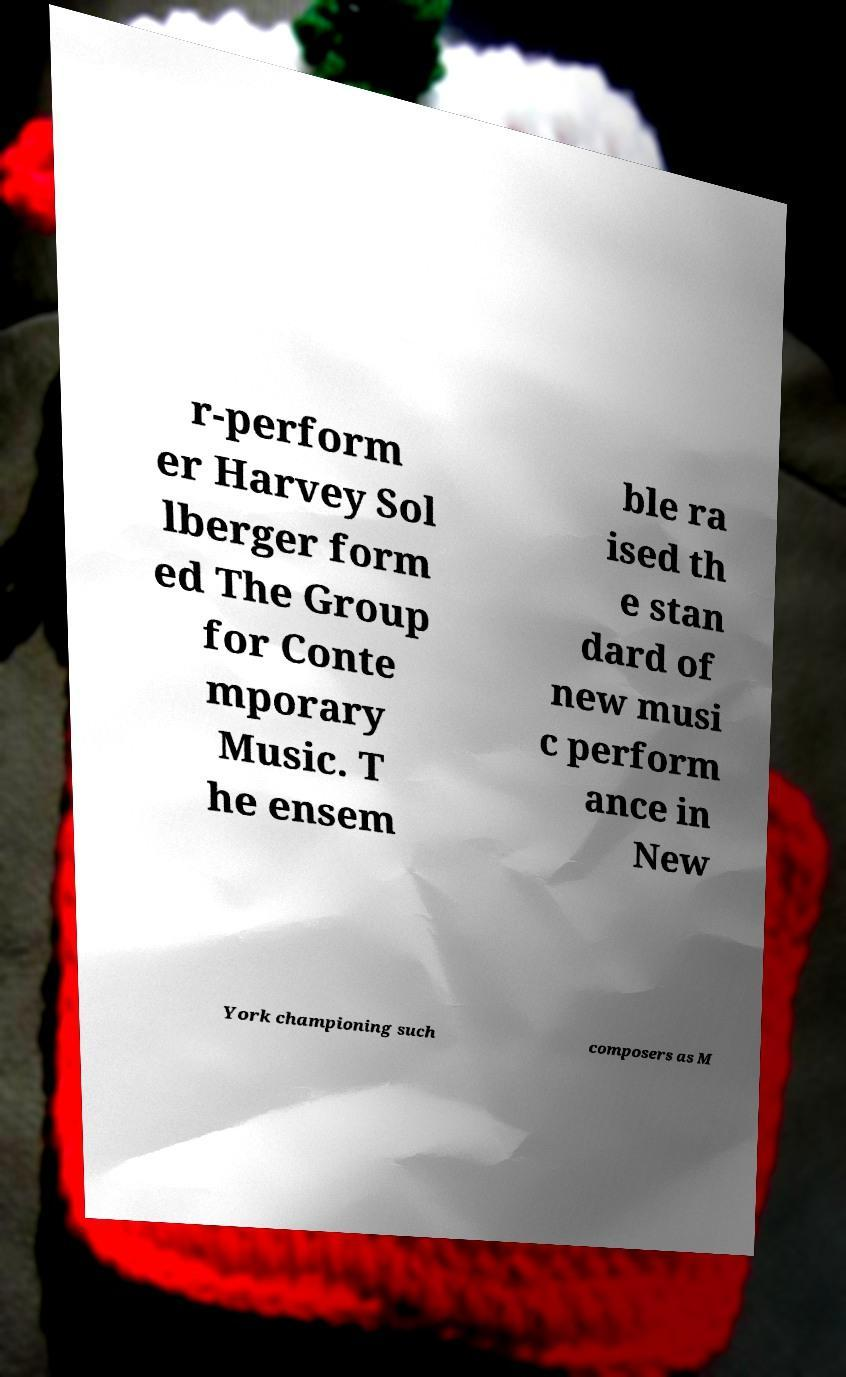Can you accurately transcribe the text from the provided image for me? r-perform er Harvey Sol lberger form ed The Group for Conte mporary Music. T he ensem ble ra ised th e stan dard of new musi c perform ance in New York championing such composers as M 